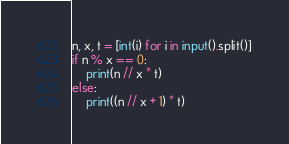Convert code to text. <code><loc_0><loc_0><loc_500><loc_500><_Python_>

n, x, t = [int(i) for i in input().split()]
if n % x == 0:
    print(n // x * t)
else:
    print((n // x + 1) * t)
</code> 